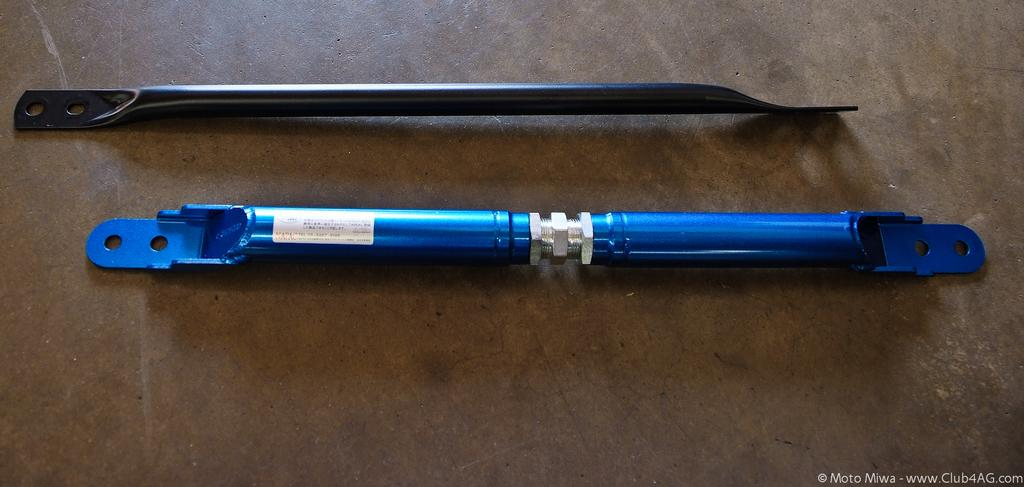What is present in the image that is not a metal object? There is a sticker in the image that is not a metal object. How many metal objects are in the image? There are two metal objects in the image. Where are the metal objects located? The metal objects are on a surface in the image. What type of fiction is the sticker promoting in the image? There is no indication of any fiction or book promotion in the image; it only features a sticker and two metal objects on a surface. 